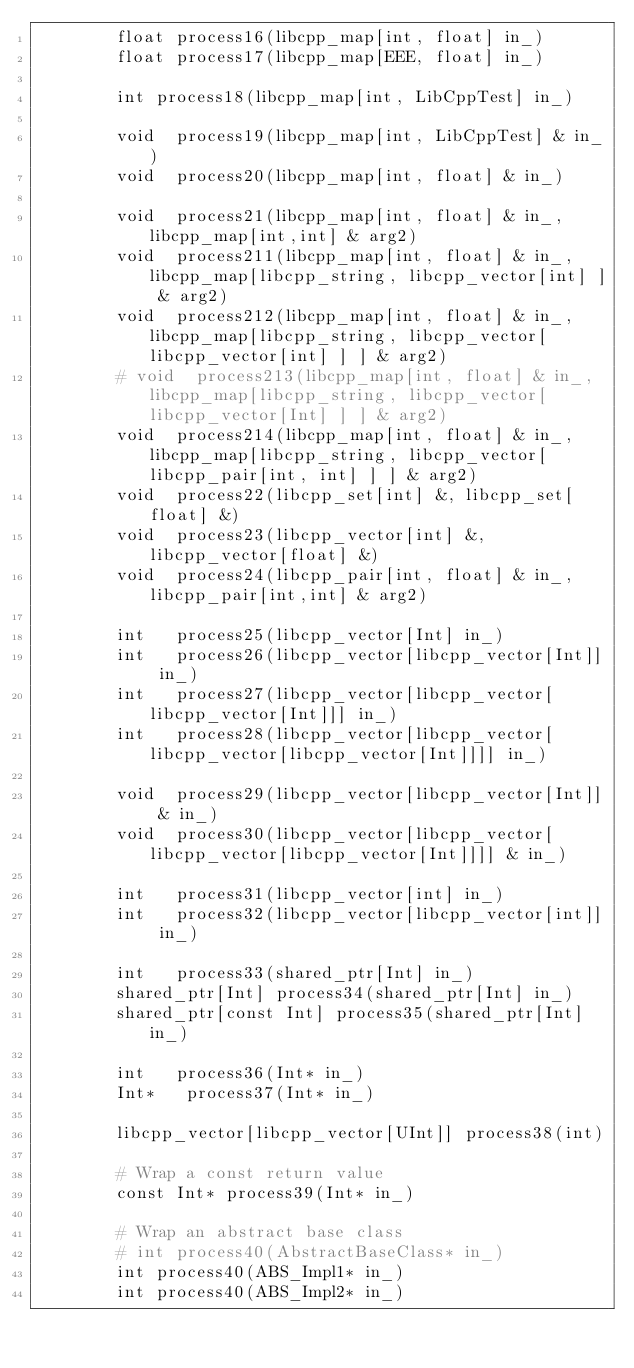Convert code to text. <code><loc_0><loc_0><loc_500><loc_500><_Cython_>        float process16(libcpp_map[int, float] in_)
        float process17(libcpp_map[EEE, float] in_)

        int process18(libcpp_map[int, LibCppTest] in_)

        void  process19(libcpp_map[int, LibCppTest] & in_)
        void  process20(libcpp_map[int, float] & in_)

        void  process21(libcpp_map[int, float] & in_, libcpp_map[int,int] & arg2)
        void  process211(libcpp_map[int, float] & in_, libcpp_map[libcpp_string, libcpp_vector[int] ] & arg2)
        void  process212(libcpp_map[int, float] & in_, libcpp_map[libcpp_string, libcpp_vector[ libcpp_vector[int] ] ] & arg2)
        # void  process213(libcpp_map[int, float] & in_, libcpp_map[libcpp_string, libcpp_vector[ libcpp_vector[Int] ] ] & arg2)
        void  process214(libcpp_map[int, float] & in_, libcpp_map[libcpp_string, libcpp_vector[ libcpp_pair[int, int] ] ] & arg2)
        void  process22(libcpp_set[int] &, libcpp_set[float] &)
        void  process23(libcpp_vector[int] &, libcpp_vector[float] &)
        void  process24(libcpp_pair[int, float] & in_, libcpp_pair[int,int] & arg2)

        int   process25(libcpp_vector[Int] in_)
        int   process26(libcpp_vector[libcpp_vector[Int]] in_)
        int   process27(libcpp_vector[libcpp_vector[libcpp_vector[Int]]] in_)
        int   process28(libcpp_vector[libcpp_vector[libcpp_vector[libcpp_vector[Int]]]] in_)

        void  process29(libcpp_vector[libcpp_vector[Int]] & in_)
        void  process30(libcpp_vector[libcpp_vector[libcpp_vector[libcpp_vector[Int]]]] & in_)

        int   process31(libcpp_vector[int] in_)
        int   process32(libcpp_vector[libcpp_vector[int]] in_)

        int   process33(shared_ptr[Int] in_)
        shared_ptr[Int] process34(shared_ptr[Int] in_)
        shared_ptr[const Int] process35(shared_ptr[Int] in_)

        int   process36(Int* in_)
        Int*   process37(Int* in_)

        libcpp_vector[libcpp_vector[UInt]] process38(int)

        # Wrap a const return value
        const Int* process39(Int* in_)

        # Wrap an abstract base class
        # int process40(AbstractBaseClass* in_)
        int process40(ABS_Impl1* in_)
        int process40(ABS_Impl2* in_)

</code> 